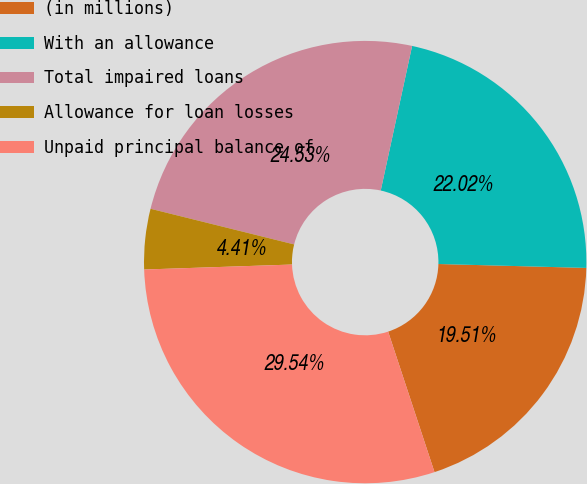Convert chart. <chart><loc_0><loc_0><loc_500><loc_500><pie_chart><fcel>(in millions)<fcel>With an allowance<fcel>Total impaired loans<fcel>Allowance for loan losses<fcel>Unpaid principal balance of<nl><fcel>19.51%<fcel>22.02%<fcel>24.53%<fcel>4.41%<fcel>29.54%<nl></chart> 